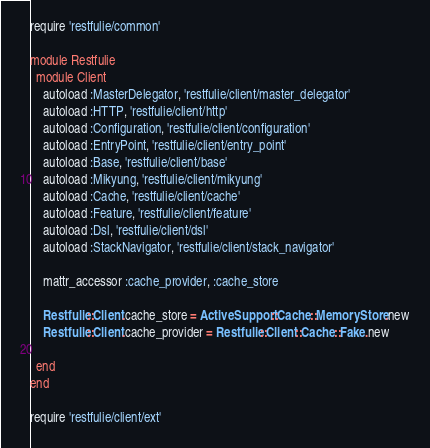<code> <loc_0><loc_0><loc_500><loc_500><_Ruby_>require 'restfulie/common'

module Restfulie
  module Client
    autoload :MasterDelegator, 'restfulie/client/master_delegator'
    autoload :HTTP, 'restfulie/client/http'
    autoload :Configuration, 'restfulie/client/configuration'
    autoload :EntryPoint, 'restfulie/client/entry_point'
    autoload :Base, 'restfulie/client/base'
    autoload :Mikyung, 'restfulie/client/mikyung'
    autoload :Cache, 'restfulie/client/cache'
    autoload :Feature, 'restfulie/client/feature'
    autoload :Dsl, 'restfulie/client/dsl'
    autoload :StackNavigator, 'restfulie/client/stack_navigator'
    
    mattr_accessor :cache_provider, :cache_store

    Restfulie::Client.cache_store = ActiveSupport::Cache::MemoryStore.new
    Restfulie::Client.cache_provider = Restfulie::Client::Cache::Fake.new

  end
end

require 'restfulie/client/ext'
</code> 